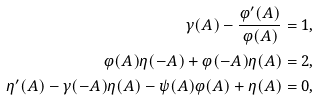<formula> <loc_0><loc_0><loc_500><loc_500>\gamma ( A ) - \frac { \varphi ^ { \prime } ( A ) } { \varphi ( A ) } & = 1 , \\ \varphi ( A ) \eta ( - A ) + \varphi ( - A ) \eta ( A ) & = 2 , \\ \eta ^ { \prime } ( A ) - \gamma ( - A ) \eta ( A ) - \psi ( A ) \varphi ( A ) + \eta ( A ) & = 0 ,</formula> 